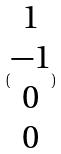<formula> <loc_0><loc_0><loc_500><loc_500>( \begin{matrix} 1 \\ - 1 \\ 0 \\ 0 \end{matrix} )</formula> 